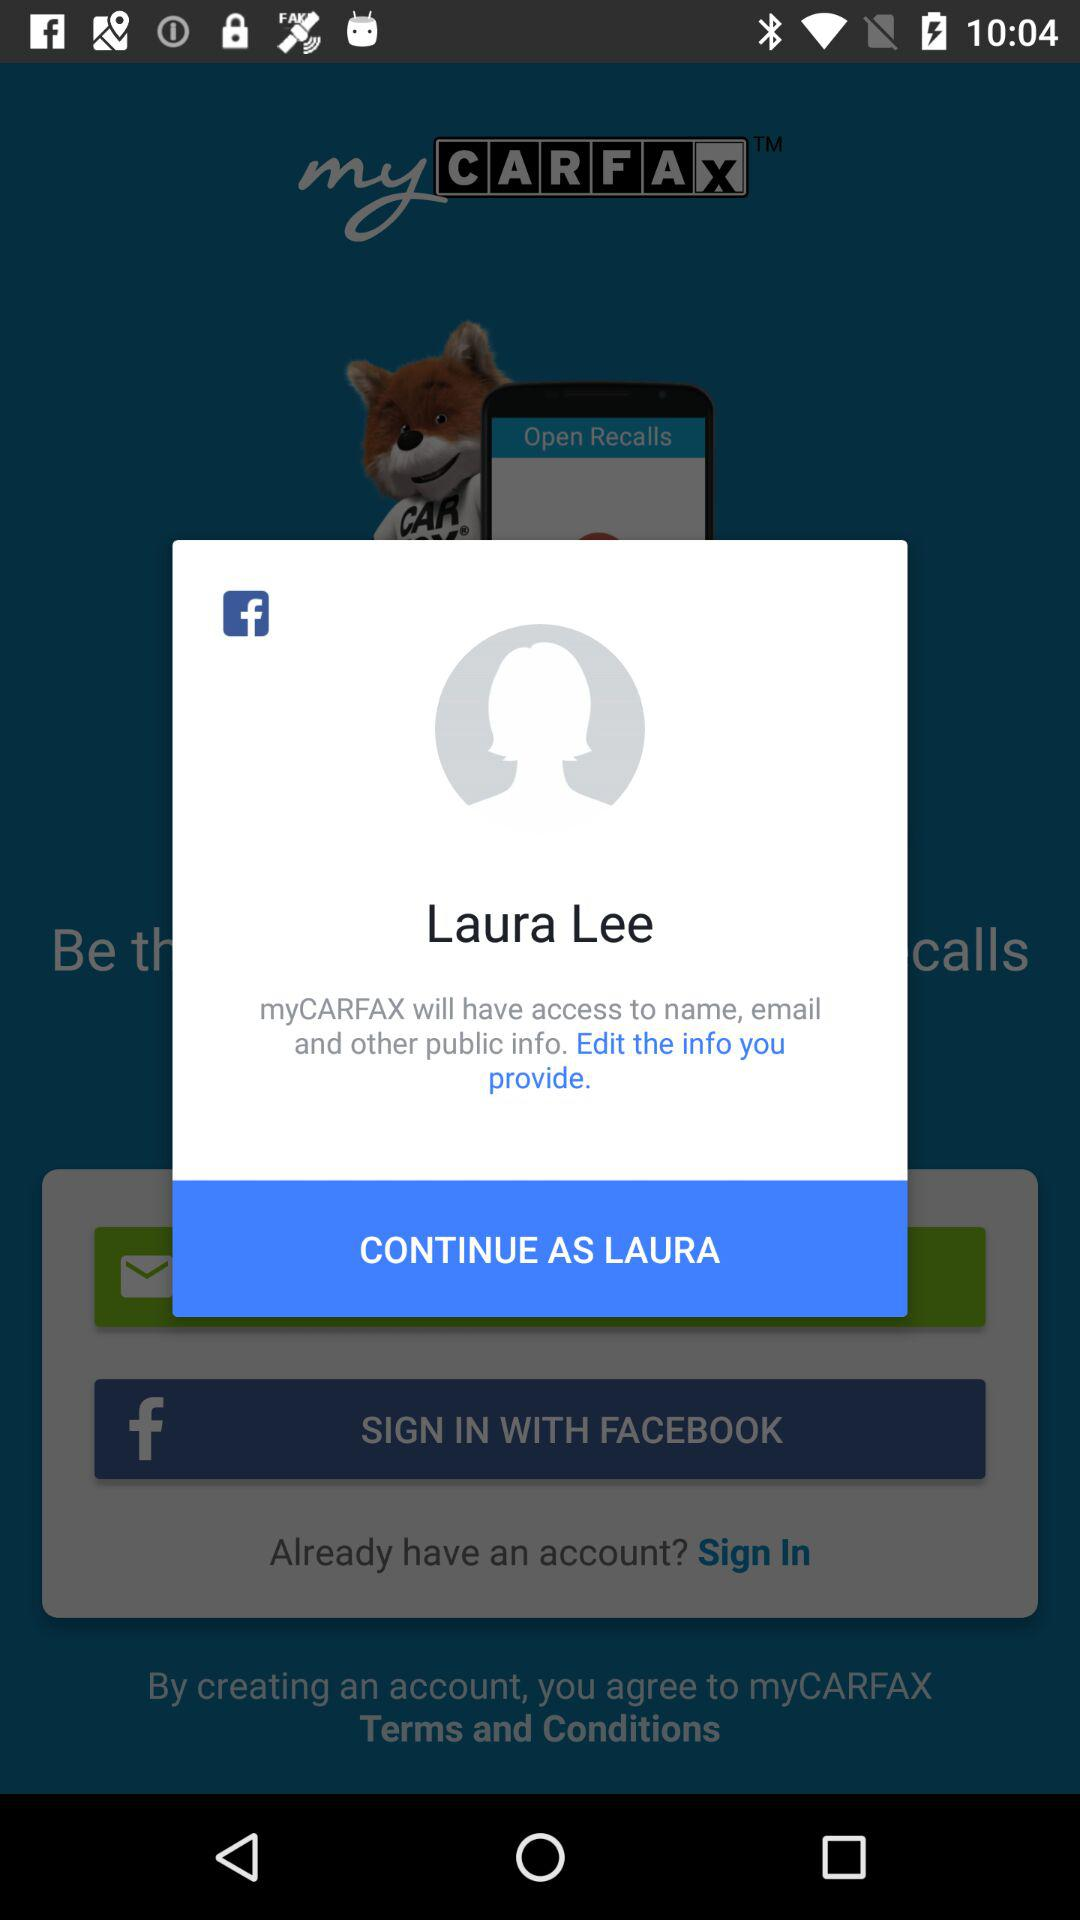What application is asking for access? The application "myCARFAX" is asking for access. 